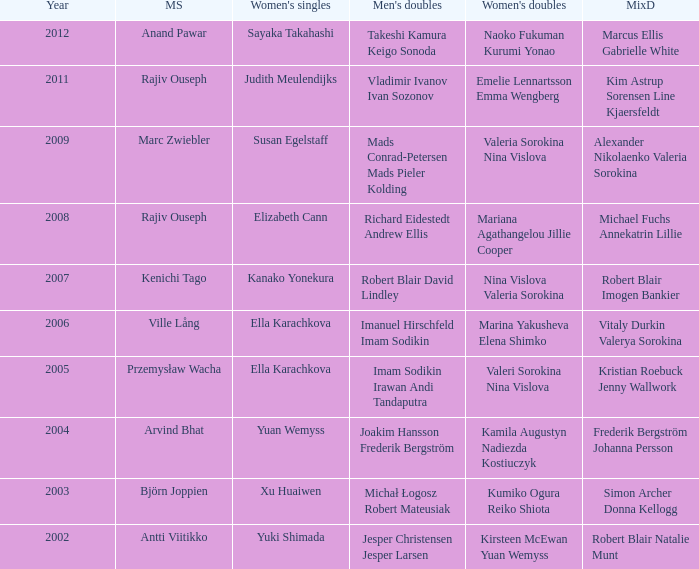What are the womens singles of imam sodikin irawan andi tandaputra? Ella Karachkova. 